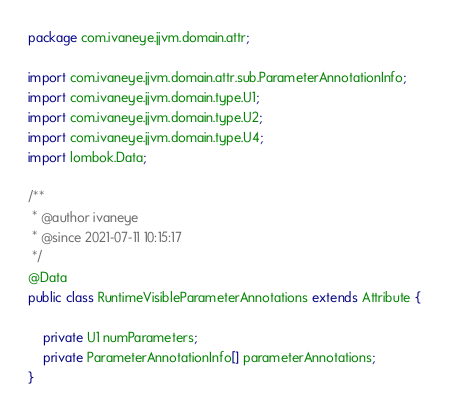Convert code to text. <code><loc_0><loc_0><loc_500><loc_500><_Java_>package com.ivaneye.jjvm.domain.attr;

import com.ivaneye.jjvm.domain.attr.sub.ParameterAnnotationInfo;
import com.ivaneye.jjvm.domain.type.U1;
import com.ivaneye.jjvm.domain.type.U2;
import com.ivaneye.jjvm.domain.type.U4;
import lombok.Data;

/**
 * @author ivaneye
 * @since 2021-07-11 10:15:17
 */
@Data
public class RuntimeVisibleParameterAnnotations extends Attribute {

    private U1 numParameters;
    private ParameterAnnotationInfo[] parameterAnnotations;
}
</code> 